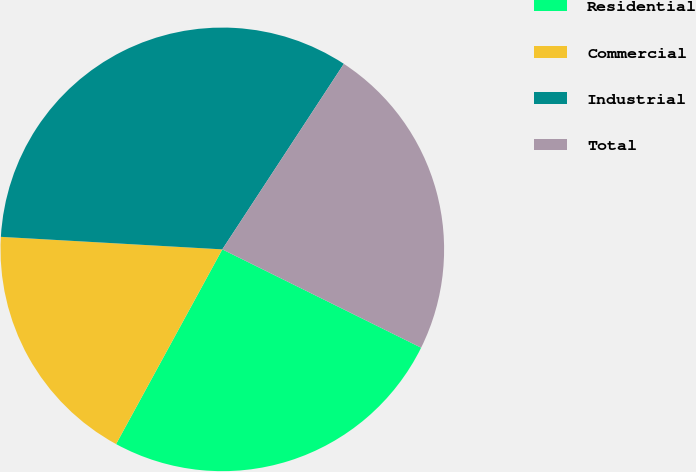Convert chart. <chart><loc_0><loc_0><loc_500><loc_500><pie_chart><fcel>Residential<fcel>Commercial<fcel>Industrial<fcel>Total<nl><fcel>25.64%<fcel>17.95%<fcel>33.33%<fcel>23.08%<nl></chart> 